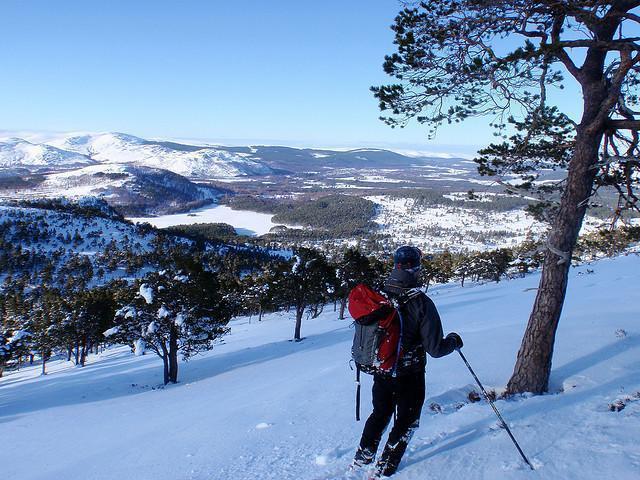What is the man doing in the snow?
Make your selection and explain in format: 'Answer: answer
Rationale: rationale.'
Options: Hiking, plowing, building snowmen, shoveling. Answer: hiking.
Rationale: He is hiking. 